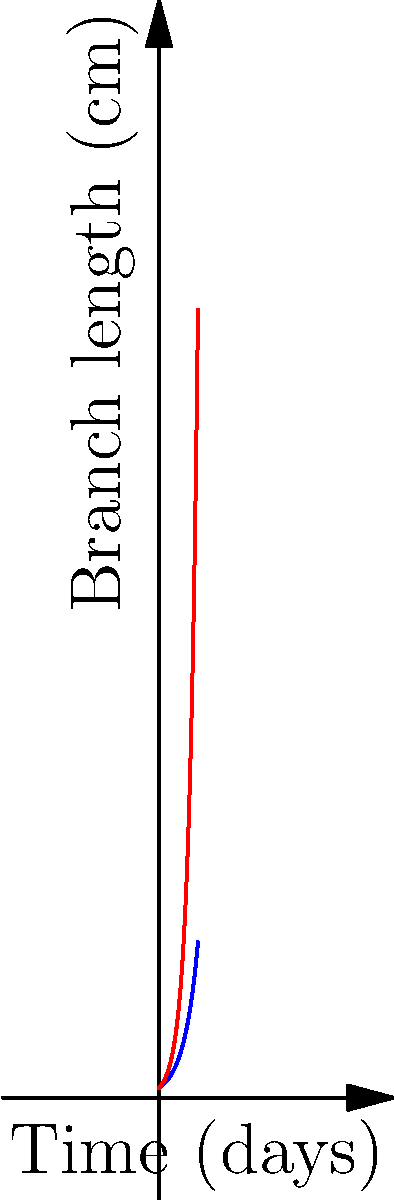In our mycological mystery, we've uncovered two distinct mycelium networks, A and B, exhibiting fractal-like branching patterns. Network A's branch length doubles each day, while network B's triples. If both networks start with a 1 cm branch, after how many days will network B's longest branch exceed network A's by more than 10 cm? Let's approach this fungal conundrum step by step:

1) First, we need to express the branch lengths as functions of time:
   Network A: $f(t) = 2^t$
   Network B: $g(t) = 3^t$
   Where $t$ is time in days.

2) We're looking for the first day when $g(t) - f(t) > 10$

3) Let's set up this inequality:
   $3^t - 2^t > 10$

4) This is a transcendental equation, so we'll solve it by trial and error:

   Day 2: $3^2 - 2^2 = 9 - 4 = 5$ (not enough)
   Day 3: $3^3 - 2^3 = 27 - 8 = 19$ (exceeds 10)

5) Therefore, on day 3, network B's longest branch will exceed network A's by more than 10 cm.

6) To verify:
   Day 2: A = 4 cm, B = 9 cm, difference = 5 cm
   Day 3: A = 8 cm, B = 27 cm, difference = 19 cm

The mycological plot thickens on the third day!
Answer: 3 days 